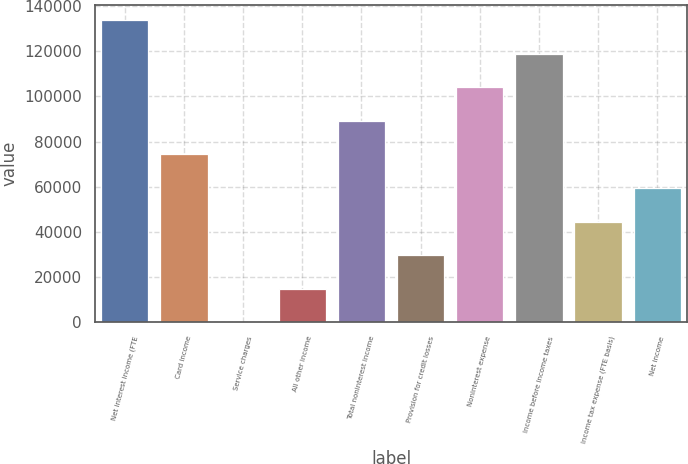Convert chart to OTSL. <chart><loc_0><loc_0><loc_500><loc_500><bar_chart><fcel>Net interest income (FTE<fcel>Card income<fcel>Service charges<fcel>All other income<fcel>Total noninterest income<fcel>Provision for credit losses<fcel>Noninterest expense<fcel>Income before income taxes<fcel>Income tax expense (FTE basis)<fcel>Net income<nl><fcel>133721<fcel>74290<fcel>1<fcel>14858.8<fcel>89147.8<fcel>29716.6<fcel>104006<fcel>118863<fcel>44574.4<fcel>59432.2<nl></chart> 